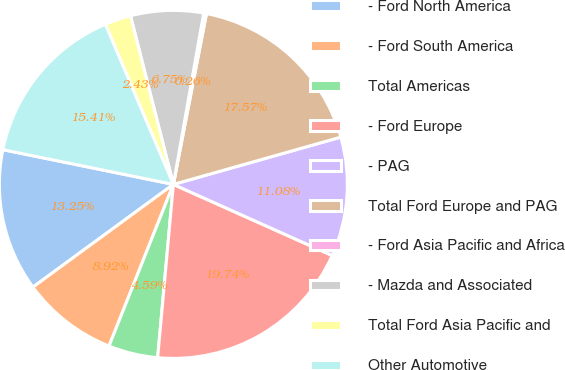Convert chart. <chart><loc_0><loc_0><loc_500><loc_500><pie_chart><fcel>- Ford North America<fcel>- Ford South America<fcel>Total Americas<fcel>- Ford Europe<fcel>- PAG<fcel>Total Ford Europe and PAG<fcel>- Ford Asia Pacific and Africa<fcel>- Mazda and Associated<fcel>Total Ford Asia Pacific and<fcel>Other Automotive<nl><fcel>13.25%<fcel>8.92%<fcel>4.59%<fcel>19.74%<fcel>11.08%<fcel>17.57%<fcel>0.26%<fcel>6.75%<fcel>2.43%<fcel>15.41%<nl></chart> 